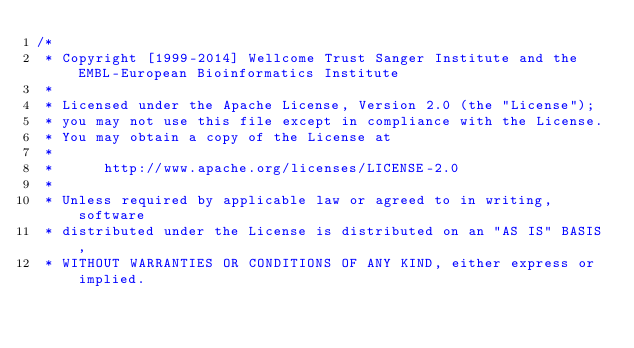<code> <loc_0><loc_0><loc_500><loc_500><_Java_>/*
 * Copyright [1999-2014] Wellcome Trust Sanger Institute and the EMBL-European Bioinformatics Institute
 * 
 * Licensed under the Apache License, Version 2.0 (the "License");
 * you may not use this file except in compliance with the License.
 * You may obtain a copy of the License at
 * 
 *      http://www.apache.org/licenses/LICENSE-2.0
 * 
 * Unless required by applicable law or agreed to in writing, software
 * distributed under the License is distributed on an "AS IS" BASIS,
 * WITHOUT WARRANTIES OR CONDITIONS OF ANY KIND, either express or implied.</code> 